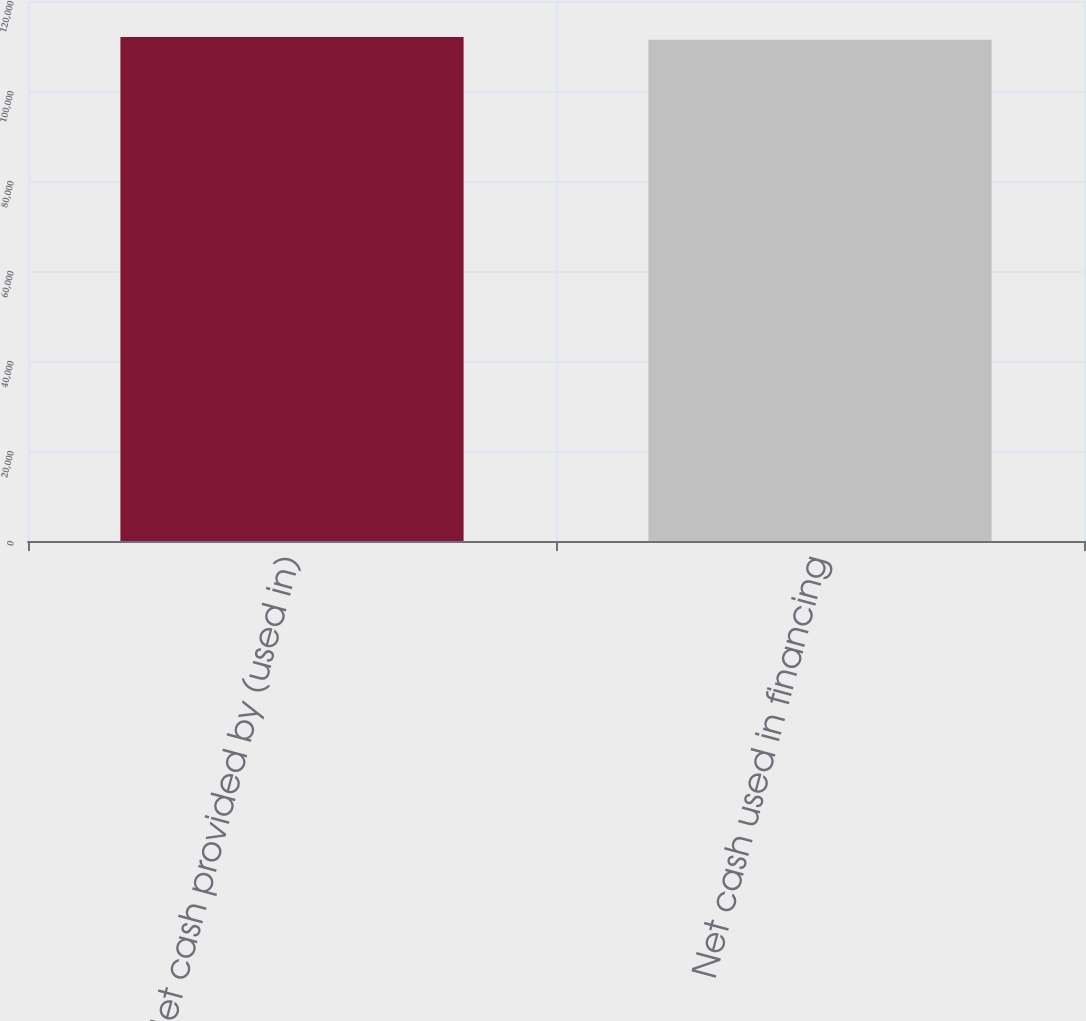<chart> <loc_0><loc_0><loc_500><loc_500><bar_chart><fcel>Net cash provided by (used in)<fcel>Net cash used in financing<nl><fcel>112027<fcel>111380<nl></chart> 